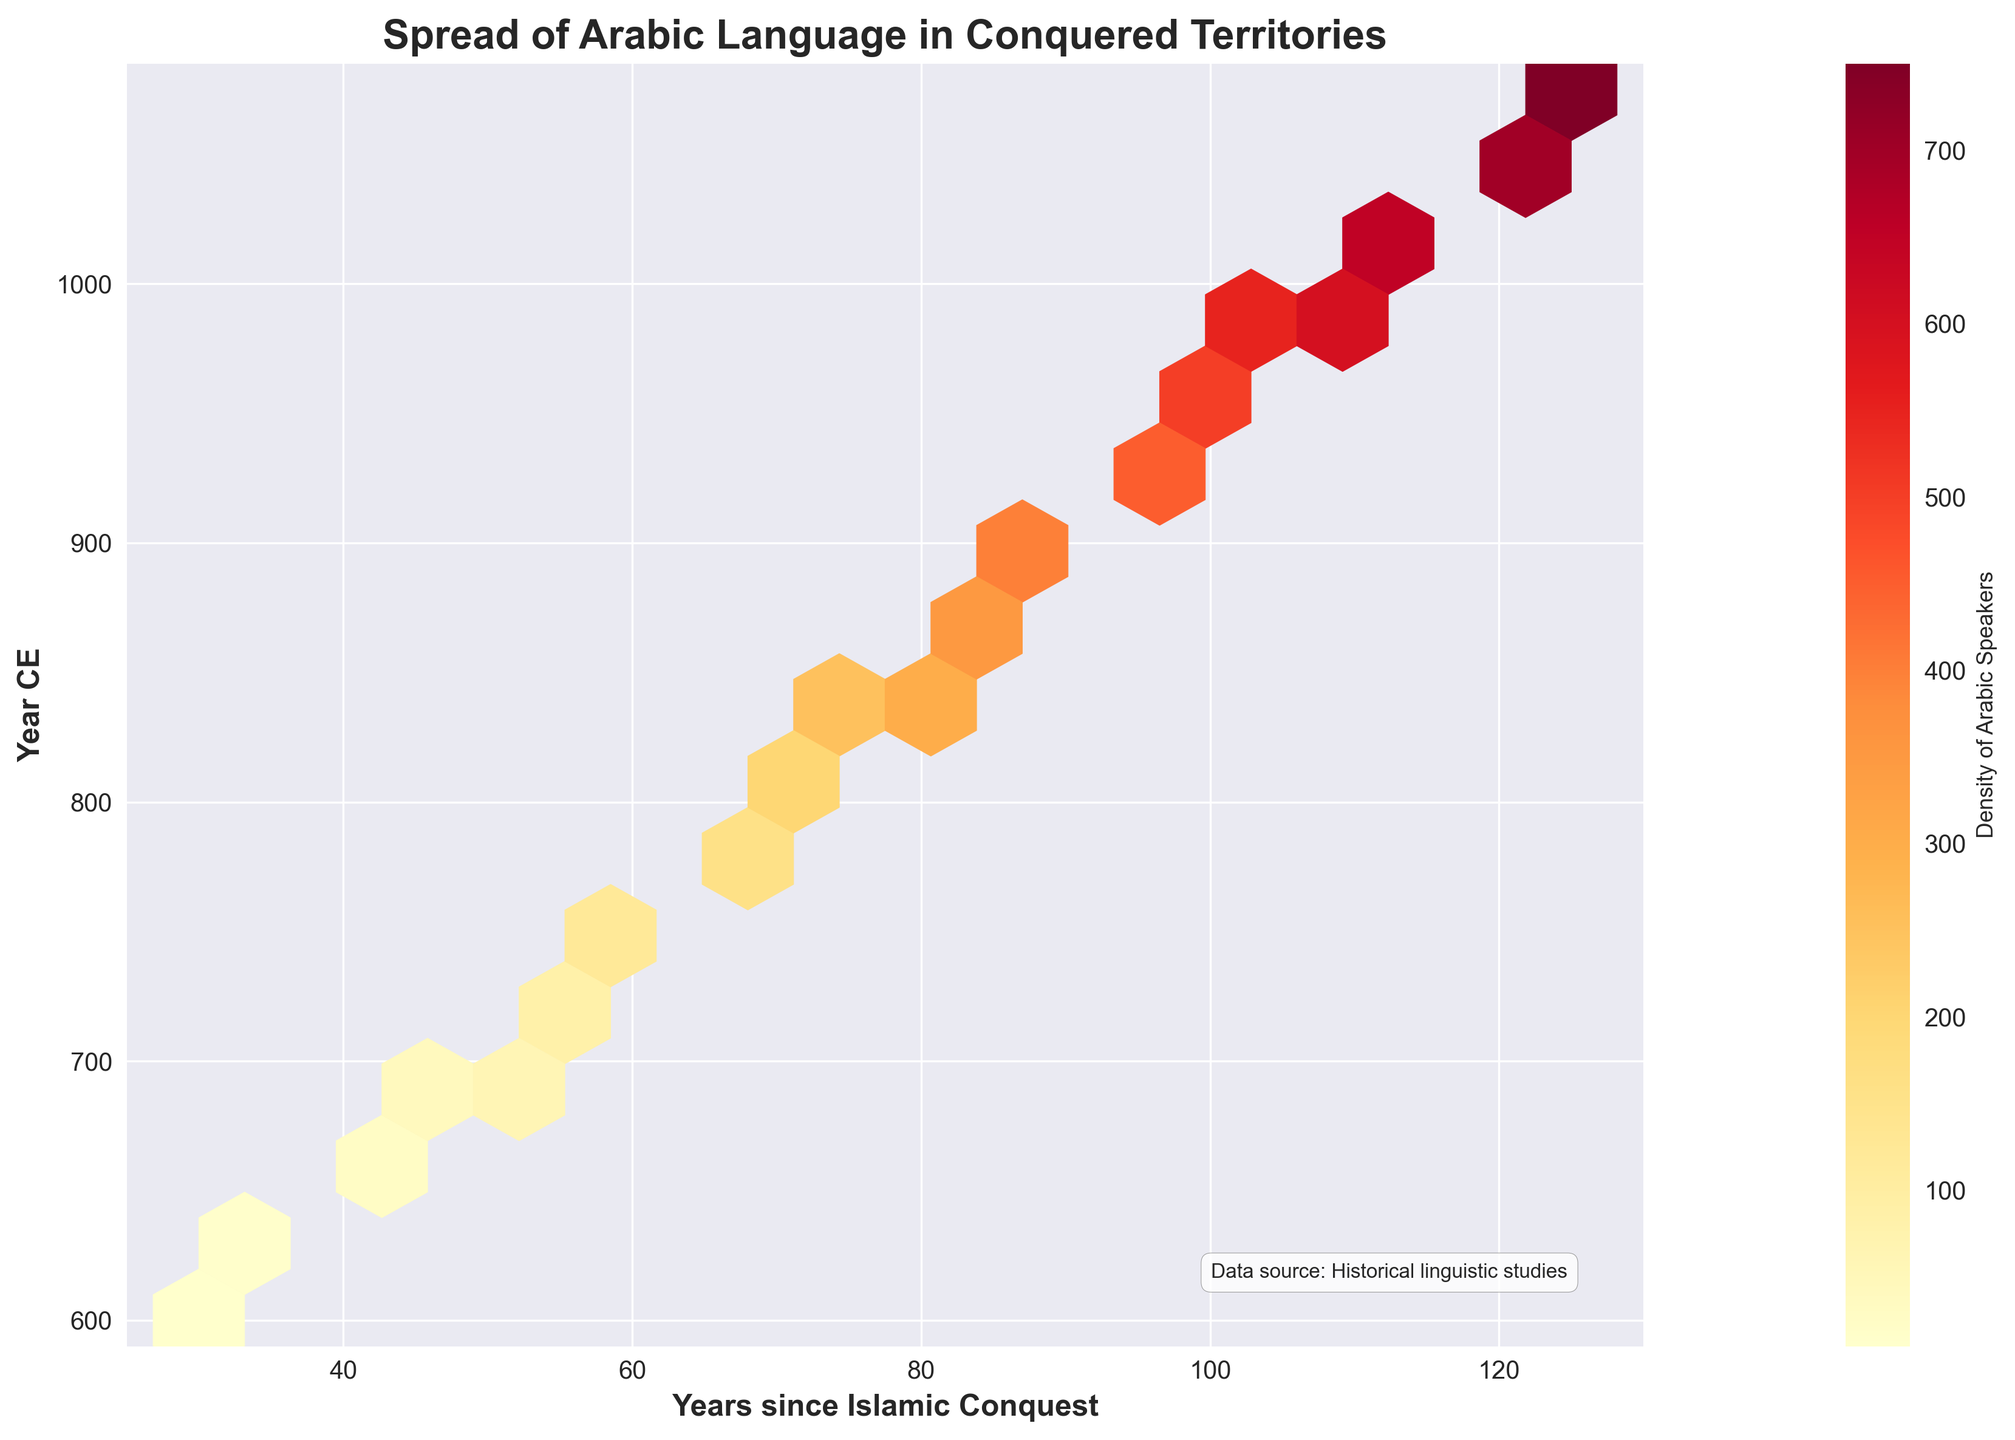What is the title of the hexbin plot? The title is displayed at the top of the plot and it is written in bold with a larger font size compared to other text elements.
Answer: Spread of Arabic Language in Conquered Territories What does the x-axis represent? The x-axis label is positioned below the horizontal axis and is written in bold with a slightly larger font size than the ticks.
Answer: Years since Islamic Conquest What does the y-axis represent? The y-axis label is positioned along the vertical axis and is written in bold with a slightly larger font size than the ticks.
Answer: Year CE How is the density of Arabic speakers represented in the hexbin plot? The color intensity in the hexagonal bins represents the density, ranging from lower to higher densities as indicated by the color gradient in the color bar.
Answer: By color intensity At approximately what year since the Islamic conquest does the plot show the highest density of Arabic speakers? The brightest hexagons indicate the highest densities. These areas are roughly around the x-value of 100 years since the Islamic conquest.
Answer: Around 100 years Describe the general trend observed in the density of Arabic speakers over time. By observing the color gradient across the x-axis and y-axis, it is evident that the density of Arabic speakers generally increases over time, with higher densities appearing in later years.
Answer: Increasing over time Around which year CE does the plot show a significant rise in the density of Arabic speakers? By examining the color intensity shift vertically on the y-axis between different years, the significant rise becomes noticeable around the year 800 CE and continues to rise steadily thereafter.
Answer: Around 800 CE Compare the density of Arabic speakers in the years 700 CE and 900 CE. Which year shows a higher density and by how much? The brighter color and higher density value in the hexbin plot indicate a stronger concentration. The year 900 CE shows more highlighted hexagons with higher density ranges. The exact densities are not directly readable but 900 CE clearly shows a higher density.
Answer: 900 CE Based on the plot, what can be inferred about the spread of the Arabic language in the first century after the Islamic conquest? Observing the leftmost section of the plot (within 30-45 years post-conquest) shows fewer and lighter hexagons, indicating that the spread was relatively limited during the initial years.
Answer: Relatively limited spread What is the significance of the color bar on the right side of the plot? The color bar acts as a legend for the hexbin plot, illustrating how the different color intensities correspond to different densities of Arabic speakers. The lowest density is represented by the lightest color, while the highest density is shown in the darkest shade.
Answer: It indicates density levels 